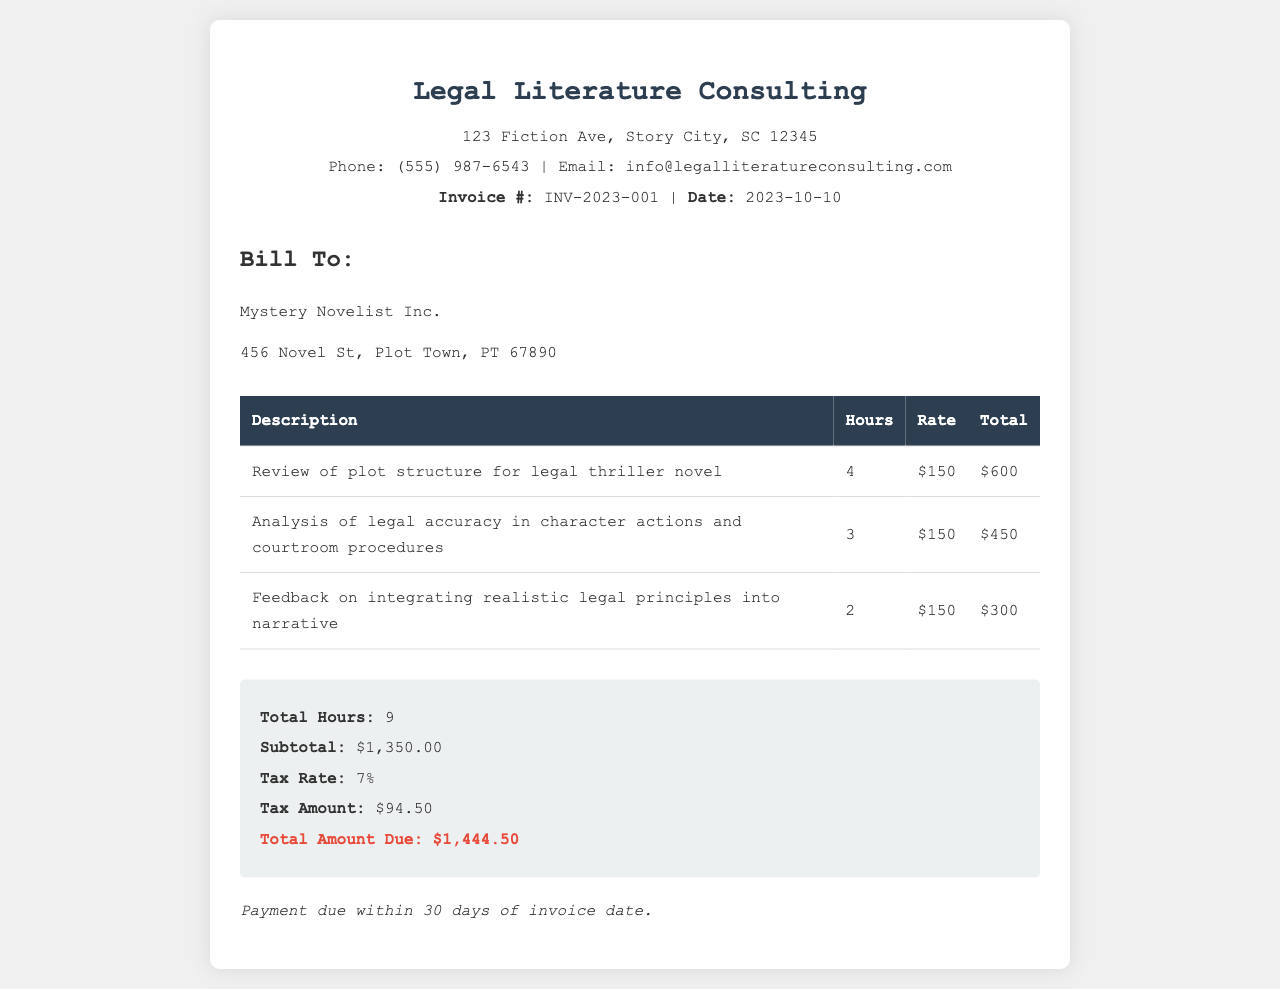What is the invoice number? The invoice number is identified in the header as INV-2023-001.
Answer: INV-2023-001 What is the total amount due? The total amount due is specified in the summary section, highlighted for emphasis.
Answer: $1,444.50 How many hours were spent on the review of plot structure? The hours for each task are listed in the table, with 4 hours specifically noted for this task.
Answer: 4 What is the subtotal before tax? The subtotal is provided in the summary section, explicitly stated.
Answer: $1,350.00 What rate is charged per hour? The hourly rate is mentioned alongside each service in the table, consistently at $150.
Answer: $150 How much tax is applied? The tax amount is shown in the summary, calculated based on the subtotal and tax rate.
Answer: $94.50 Who is the invoice billed to? The "Bill To" section contains the name of the entity being billed.
Answer: Mystery Novelist Inc How many total hours were billed? The total hours are summed and noted in the summary section of the invoice.
Answer: 9 What is the payment term? The payment term is specified at the end of the document, indicating the due duration.
Answer: Payment due within 30 days of invoice date 